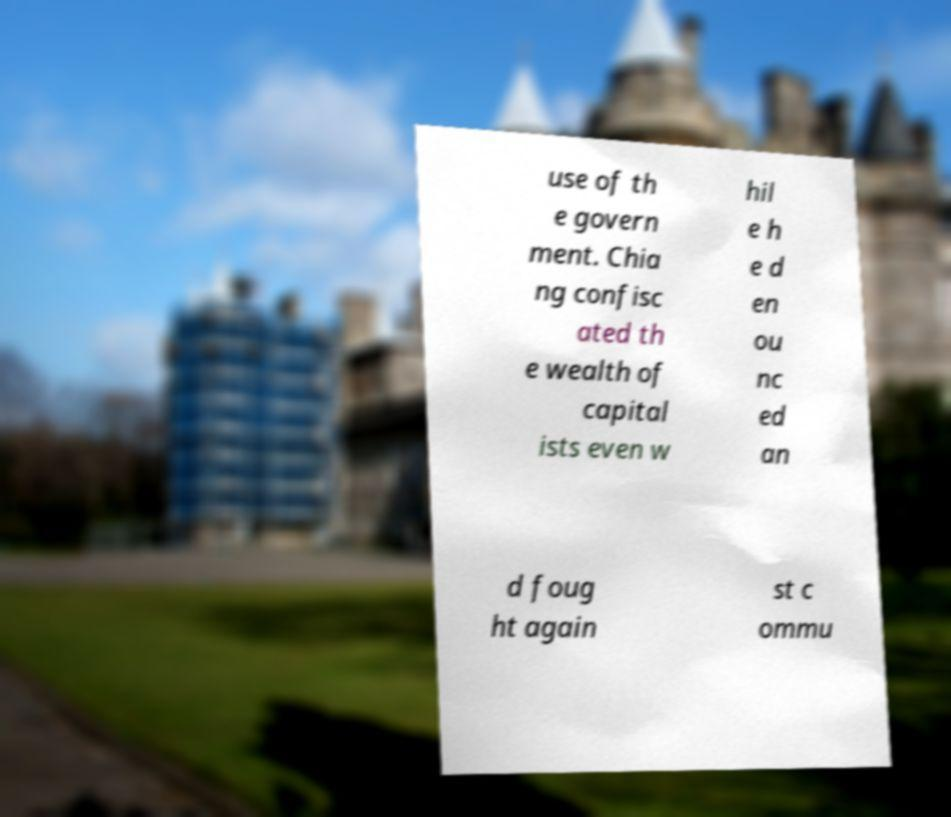Can you accurately transcribe the text from the provided image for me? use of th e govern ment. Chia ng confisc ated th e wealth of capital ists even w hil e h e d en ou nc ed an d foug ht again st c ommu 